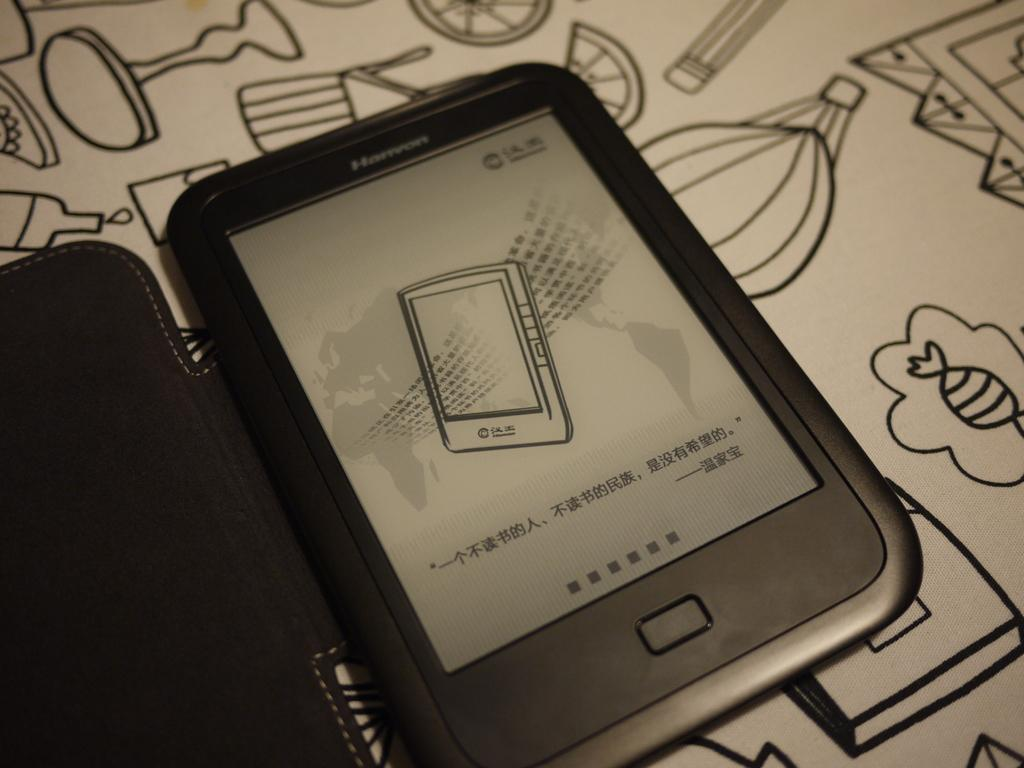What electronic device is visible in the image? There is a mobile phone in the image. What is the mobile phone placed on? The mobile phone is placed on a white object. What type of reaction can be seen in the image? There is no reaction visible in the image; it only shows a mobile phone placed on a white object. 